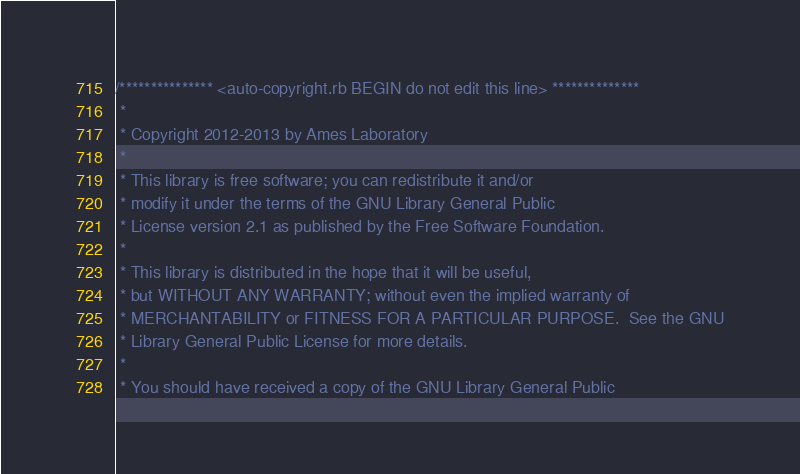<code> <loc_0><loc_0><loc_500><loc_500><_C++_>/*************** <auto-copyright.rb BEGIN do not edit this line> **************
 *
 * Copyright 2012-2013 by Ames Laboratory
 *
 * This library is free software; you can redistribute it and/or
 * modify it under the terms of the GNU Library General Public
 * License version 2.1 as published by the Free Software Foundation.
 *
 * This library is distributed in the hope that it will be useful,
 * but WITHOUT ANY WARRANTY; without even the implied warranty of
 * MERCHANTABILITY or FITNESS FOR A PARTICULAR PURPOSE.  See the GNU
 * Library General Public License for more details.
 *
 * You should have received a copy of the GNU Library General Public</code> 